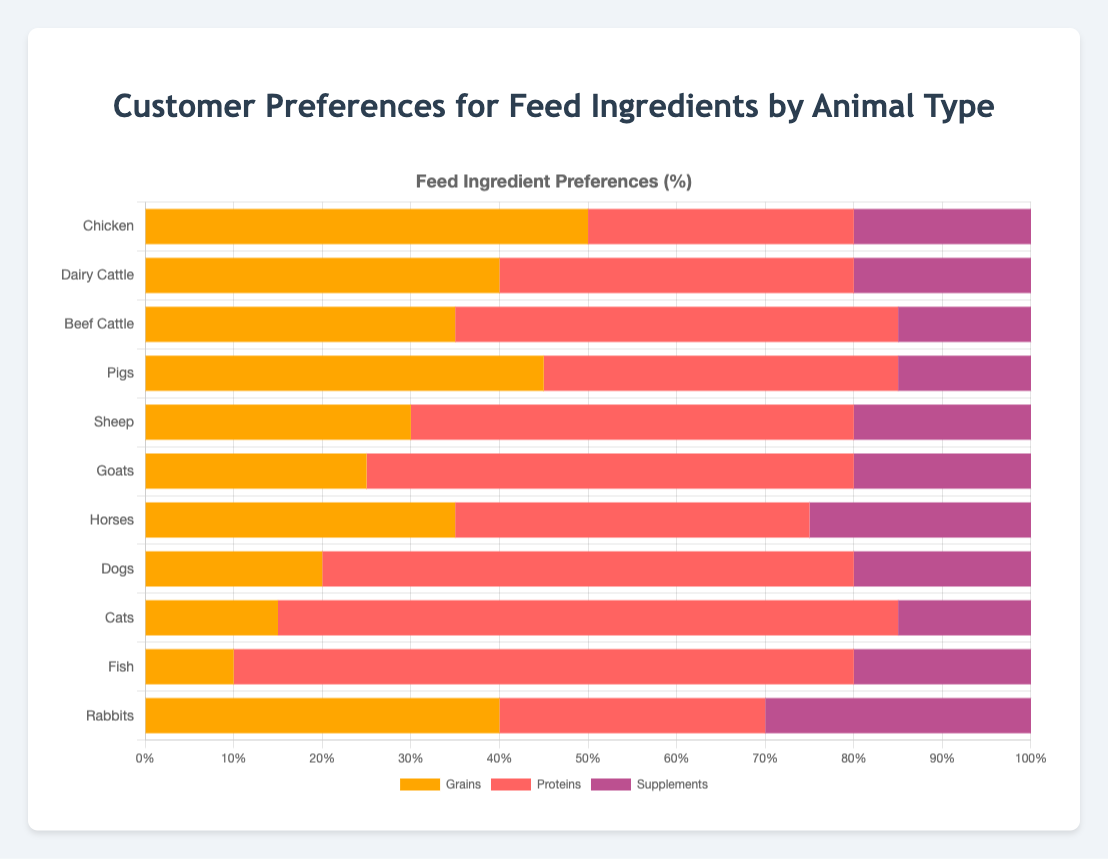Which animal prefers proteins the most? Look at the protein percentages. Cats and Fish both have the highest protein preference at 70%.
Answer: Cats and Fish What is the total preference percentage for grains across all animals? Sum the grain percentages: 50 + 40 + 35 + 45 + 30 + 25 + 35 + 20 + 15 + 10 + 40 = 345
Answer: 345 Which animal has the highest preference for supplements? Look for the highest supplement percentage in the chart. Rabbits have the highest at 30%.
Answer: Rabbits Do pigs or goats prefer proteins more? Compare the protein percentages for pigs (40%) and goats (55%). Goats prefer proteins more.
Answer: Goats Which animal type shows equal preference for grains and supplements? Check where the grain percentage equals the supplement percentage. No animal fits this criterion.
Answer: None What is the average preference percentage for supplements across all animals? Sum the supplement percentages: 20 + 20 + 15 + 15 + 20 + 20 + 25 + 20 + 15 + 20 + 30 = 220. Divide by the number of animals (11): 220/11 = 20
Answer: 20 Which group prefers grains the most, and by how much more compared to dogs? Chickens prefer grains the most at 50%, and dogs prefer grains at 20%. The difference: 50 - 20 = 30.
Answer: Chickens, 30% Is there any animal where the preference for grains is exactly twice the preference for supplements? Check if 2 * supplement percentage equals grain percentage for any animal. For pigs, 2 * 15 = 30, which does not equal 45. None meet this criterion.
Answer: None What is the sum of the grain preferences for Chickens and Dairy Cattle? Add grain preferences: 50 (Chickens) + 40 (Dairy Cattle) = 90
Answer: 90 Do Sheep prefer grains or supplements more? Compare preference percentages for Sheep: grains (30%) and supplements (20%). Sheep prefer grains more.
Answer: Grains 